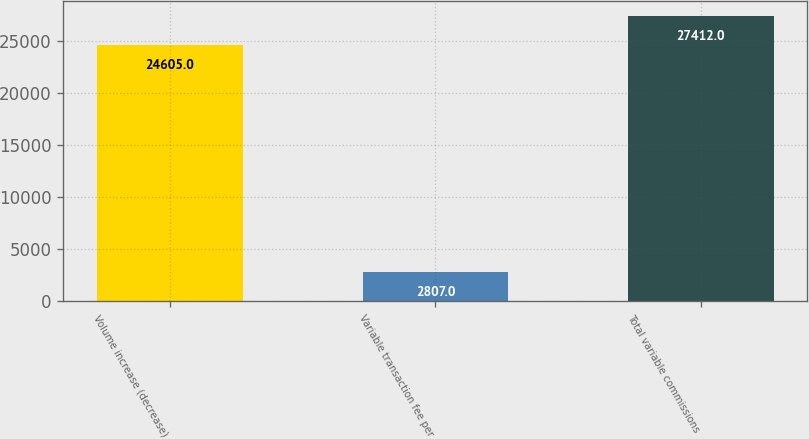Convert chart. <chart><loc_0><loc_0><loc_500><loc_500><bar_chart><fcel>Volume increase (decrease)<fcel>Variable transaction fee per<fcel>Total variable commissions<nl><fcel>24605<fcel>2807<fcel>27412<nl></chart> 